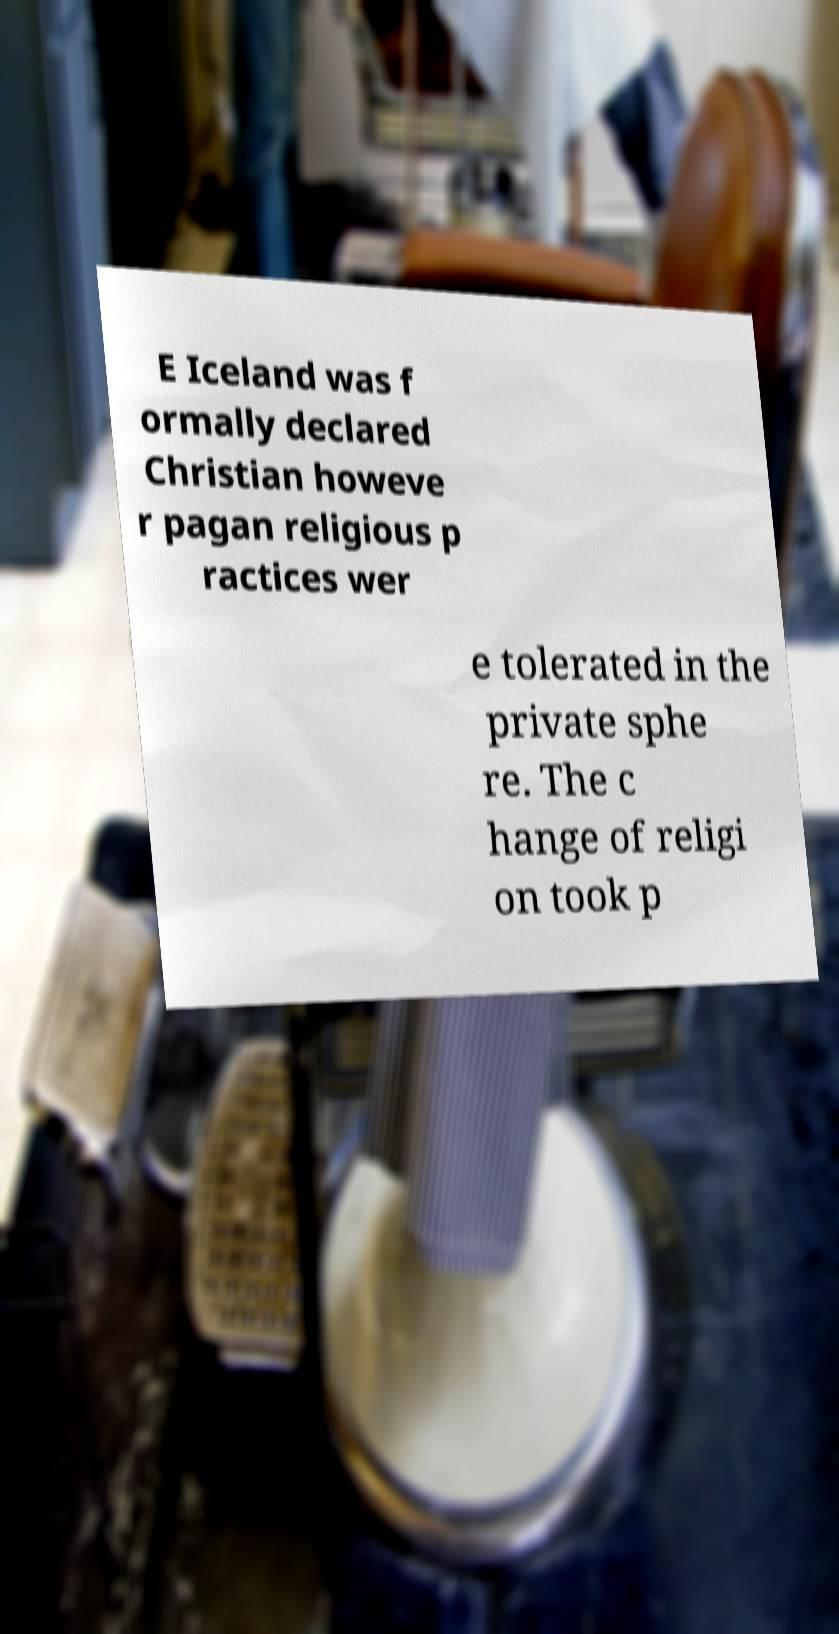There's text embedded in this image that I need extracted. Can you transcribe it verbatim? E Iceland was f ormally declared Christian howeve r pagan religious p ractices wer e tolerated in the private sphe re. The c hange of religi on took p 